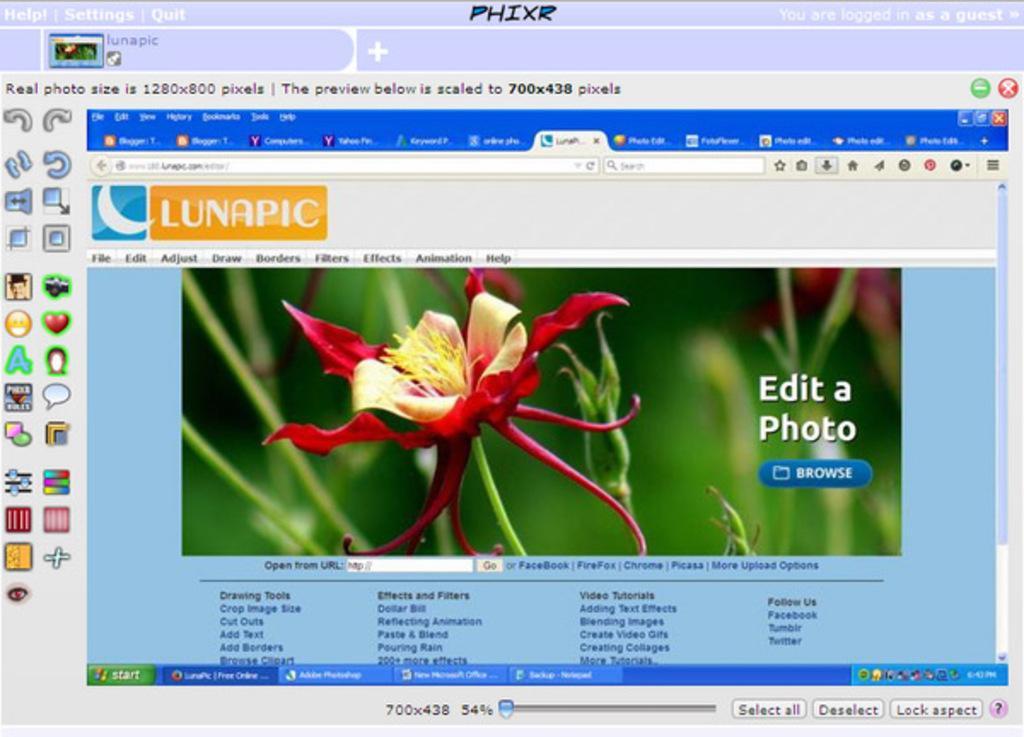Could you give a brief overview of what you see in this image? In this picture we can see a web page and on this page we can see a flower, symbols, buttons and some text. 